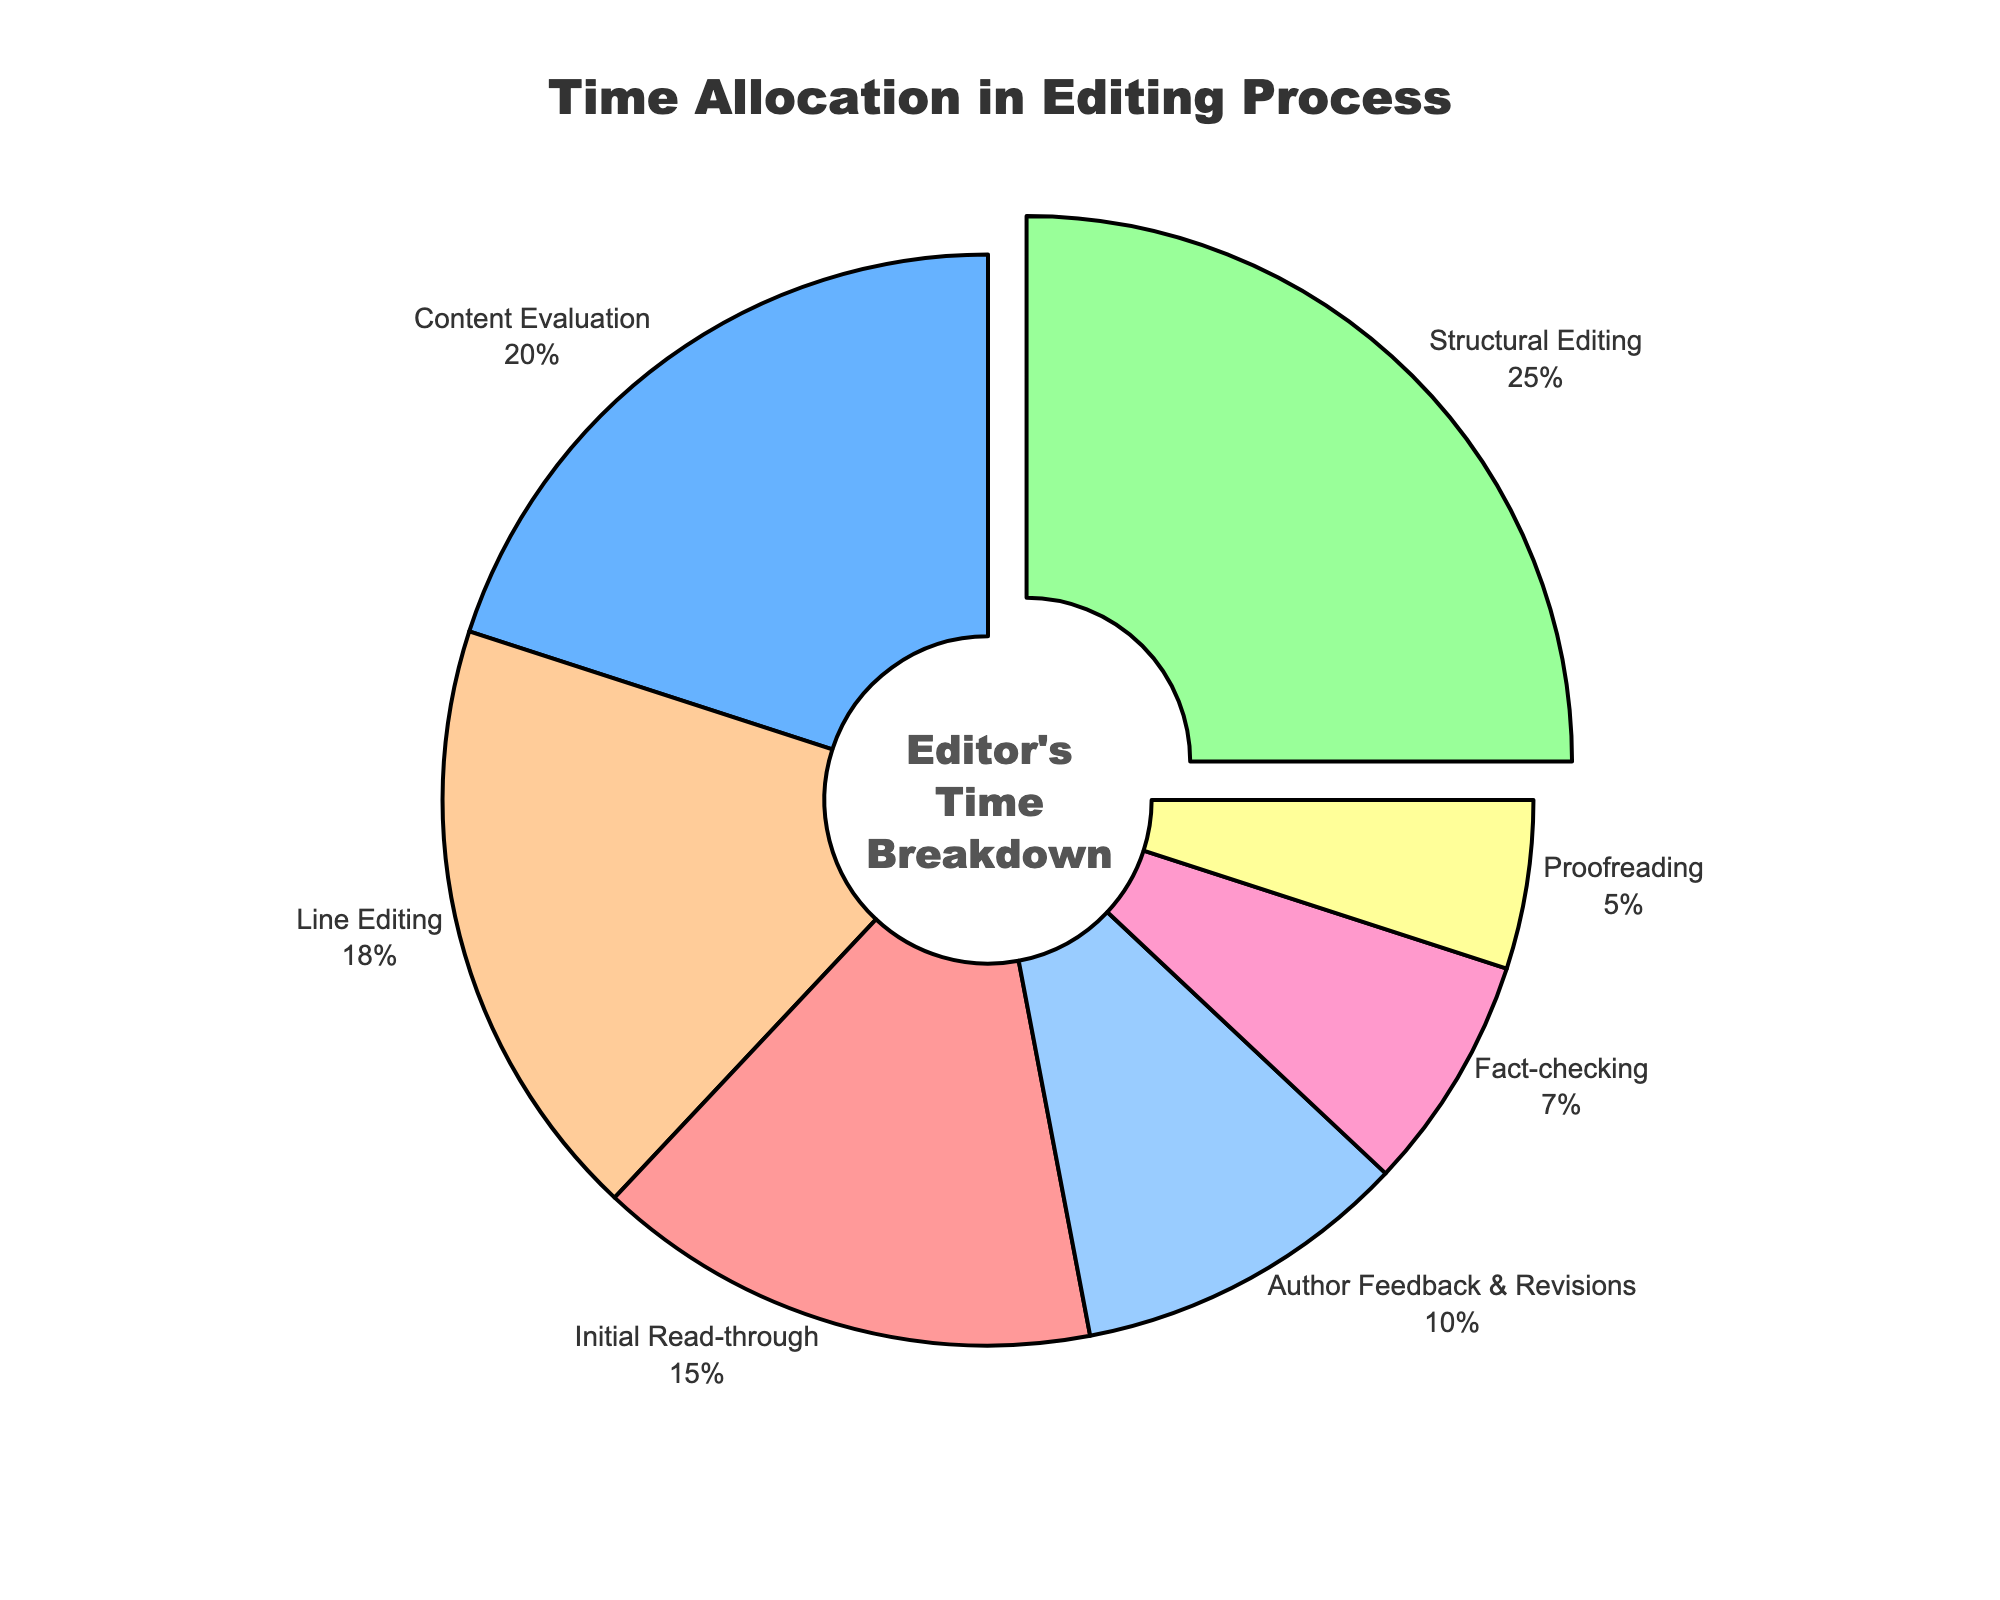What stage takes up the largest portion of the time allocation? The pie chart shows that the largest segment is Structural Editing. Additionally, this segment is slightly pulled out from the pie, highlighting it as the largest.
Answer: Structural Editing Which stage takes the least amount of time in the editing process? The pie chart indicates that Proofreading has the smallest segment compared to the other stages.
Answer: Proofreading What is the combined time percentage for Initial Read-through and Line Editing? According to the pie chart, Initial Read-through is 15% and Line Editing is 18%. Adding these together gives 15% + 18% = 33%.
Answer: 33% Is the time allocation for Fact-checking greater than that for Proofreading? The pie chart shows Fact-checking at 7% and Proofreading at 5%. Since 7% is greater than 5%, Fact-checking takes more time.
Answer: Yes Which stages together account for 50% of the time allocation? From the pie chart, Content Evaluation (20%) and Structural Editing (25%) together make 45%. Adding Initial Read-through (15%) to this gives 60%, which is more than 50%. Instead, Content Evaluation (20%) and Initial Read-through (15%) together are 35%. Adding Line Editing (18%) gives 53%, which is greater than 50%.
Answer: Content Evaluation, Structural Editing, and Line Editing What is the second largest stage in terms of time allocation? The pie chart's second largest segment, after Structural Editing (25%), is Content Evaluation (20%).
Answer: Content Evaluation Is the time spent on Author Feedback & Revisions more than twice the time spent on Proofreading? The pie chart shows Author Feedback & Revisions is 10% and Proofreading is 5%. Since 10% is exactly twice 5%, it's not more than twice.
Answer: No Which stage takes almost a quarter of the total time allocation? The chart shows the largest segment, Structural Editing, which is 25%, equating to a quarter of the total.
Answer: Structural Editing What is the sum of the time percentages for stages excluding Structural Editing? Sum the percentages of all other stages: Initial Read-through (15%), Content Evaluation (20%), Line Editing (18%), Fact-checking (7%), Author Feedback & Revisions (10%), Proofreading (5%). This gives 15 + 20 + 18 + 7 + 10 + 5 = 75%.
Answer: 75% If the combined time for Content Evaluation and Line Editing were doubled, would it exceed the time for all other stages combined? Content Evaluation is 20% and Line Editing is 18%, so doubled, they are 38 * 2 = 76%. All other stages combined (excluding Content Evaluation and Line Editing) are 100% - (20% + 18%) = 62%. Since 76% is greater than 62%, it would exceed.
Answer: Yes 